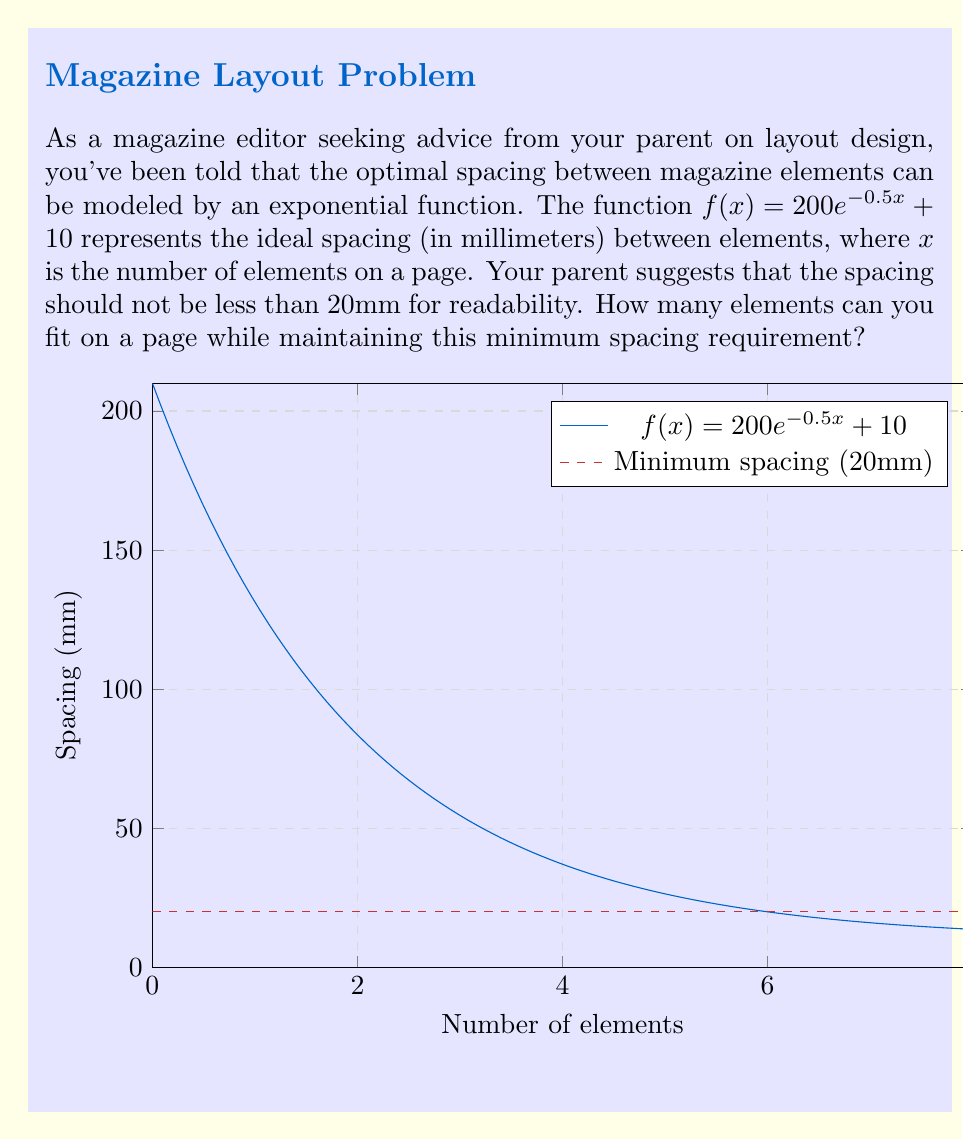Help me with this question. To solve this problem, we need to find the value of $x$ where $f(x) = 20$. This is because we want to determine the number of elements at which the spacing reaches the minimum 20mm requirement.

1) Set up the equation:
   $200e^{-0.5x} + 10 = 20$

2) Subtract 10 from both sides:
   $200e^{-0.5x} = 10$

3) Divide both sides by 200:
   $e^{-0.5x} = \frac{1}{20} = 0.05$

4) Take the natural logarithm of both sides:
   $\ln(e^{-0.5x}) = \ln(0.05)$
   $-0.5x = \ln(0.05)$

5) Divide both sides by -0.5:
   $x = -\frac{\ln(0.05)}{0.5} \approx 5.991$

6) Since we can't have a fractional number of elements, we need to round down to the nearest whole number to ensure we don't go below the 20mm spacing requirement.

Therefore, the maximum number of elements while maintaining the minimum spacing is 5.
Answer: 5 elements 